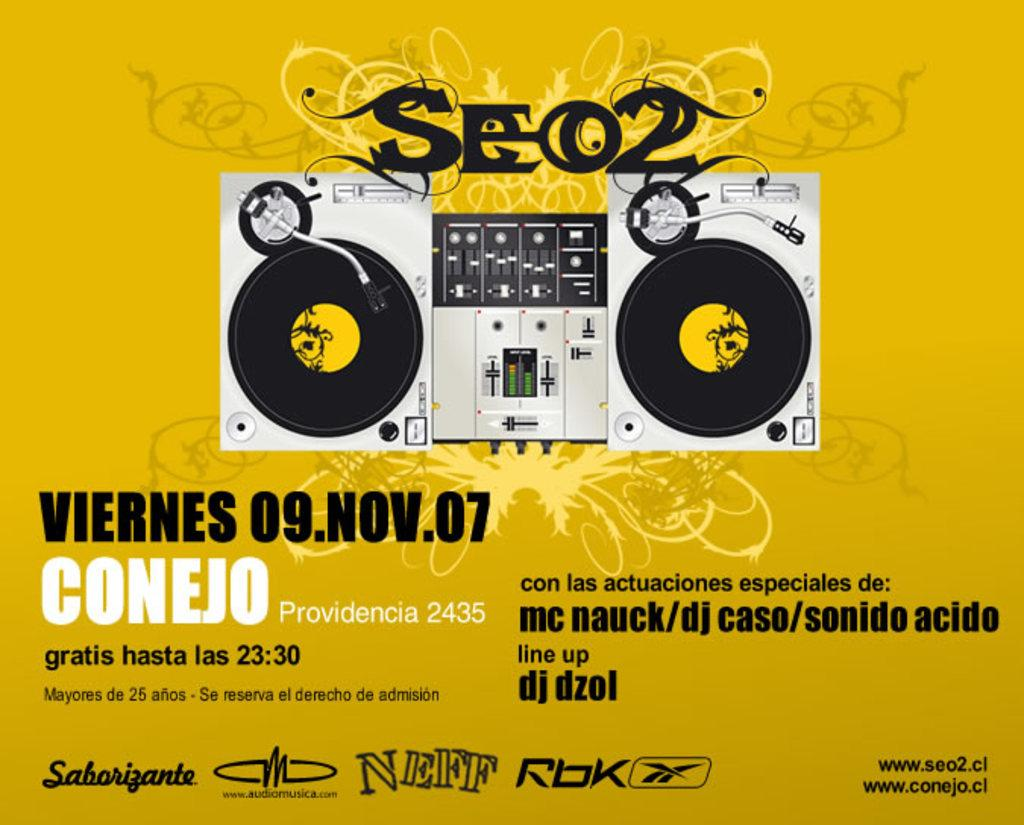<image>
Present a compact description of the photo's key features. A music festival that was held on November 9, 2007 in Provedencia, Columbia is being shown on this poster. 